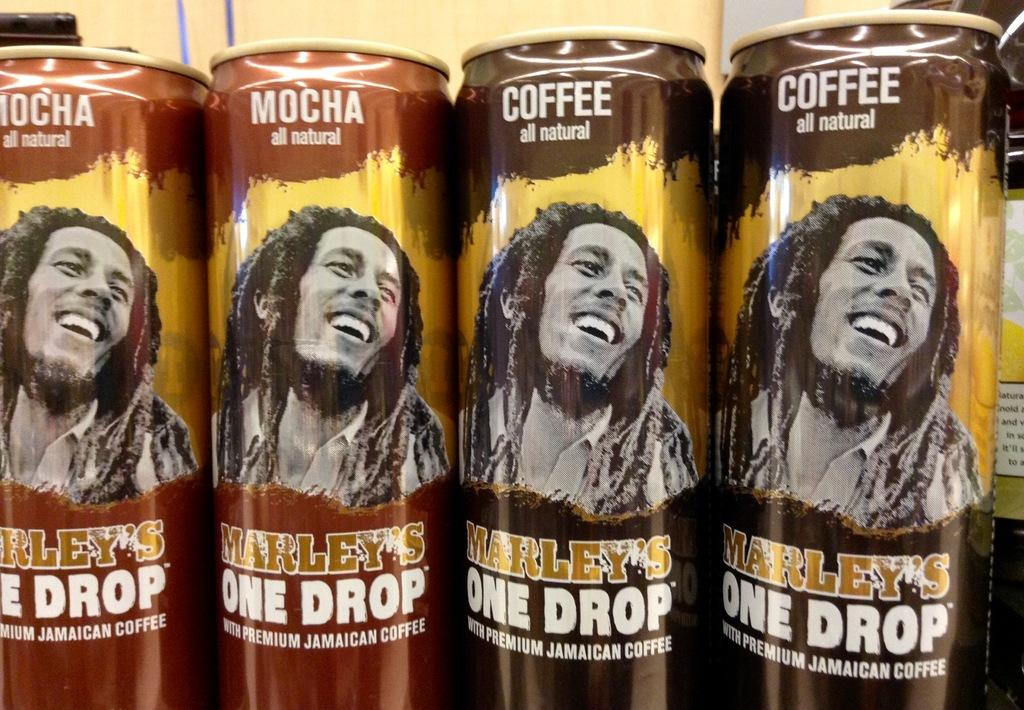Provide a one-sentence caption for the provided image. Several cans of Marley's One Drop coffees are lined up in a row. 